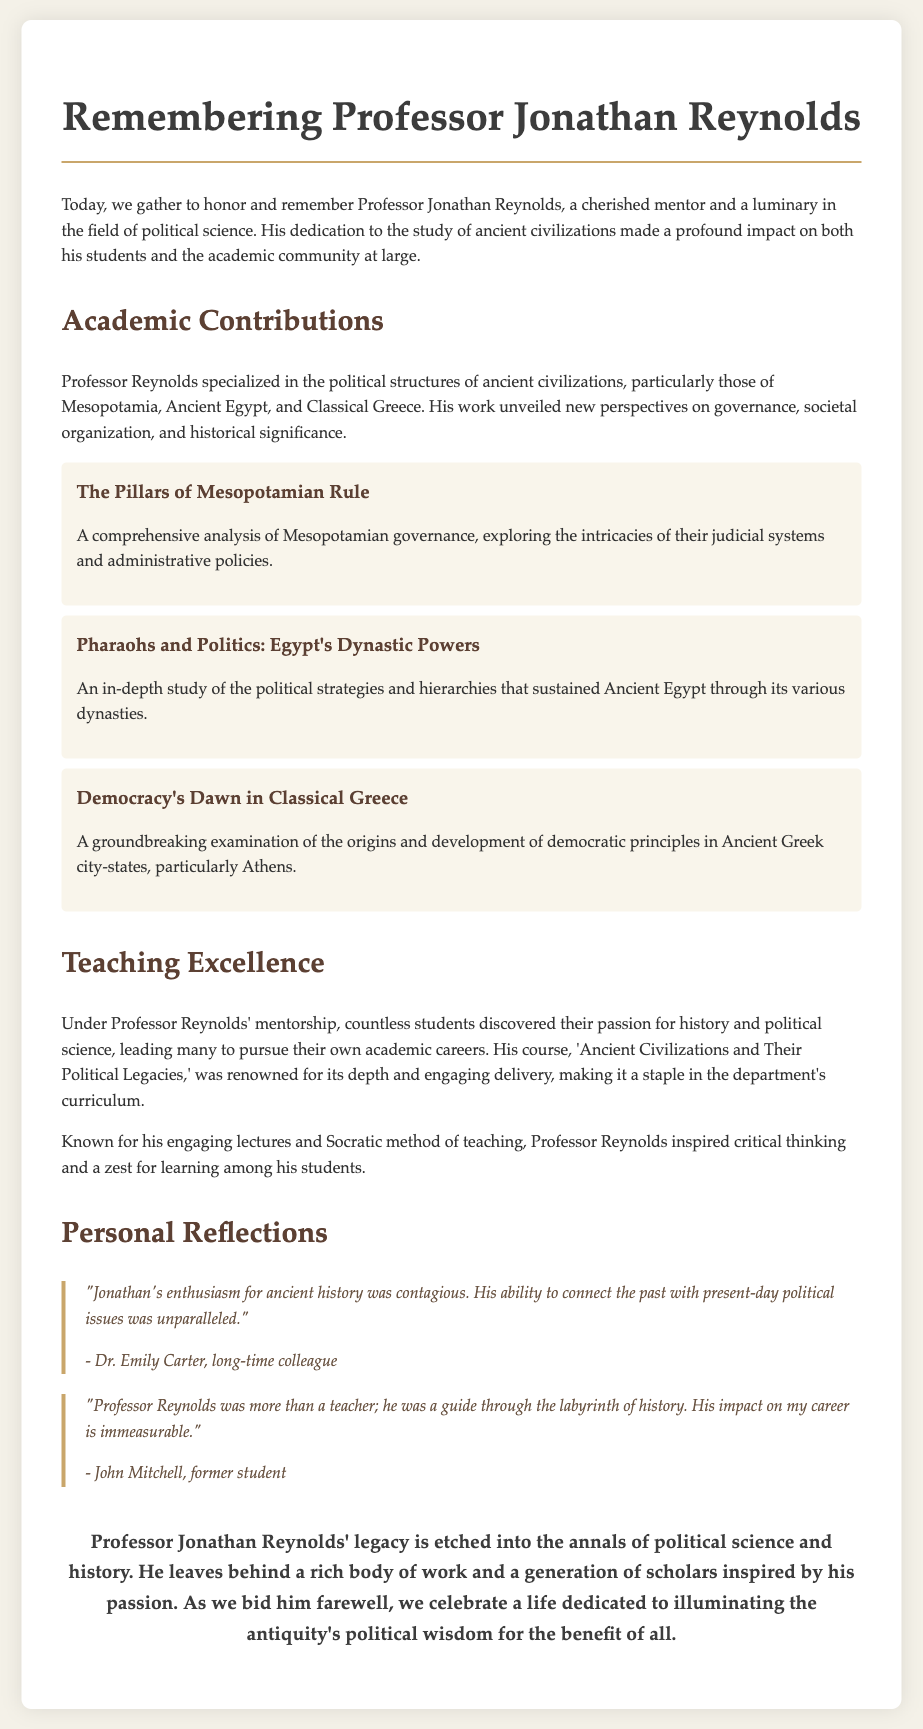What was Professor Reynolds' area of specialization? Professor Reynolds specialized in the political structures of ancient civilizations, particularly in Mesopotamia, Ancient Egypt, and Classical Greece.
Answer: political structures of ancient civilizations What is the title of Professor Reynolds' book on Mesopotamia? The document lists a specific book title focused on Mesopotamia's governance, which is "The Pillars of Mesopotamian Rule."
Answer: The Pillars of Mesopotamian Rule Who described Professor Reynolds' teaching enthusiasm? Dr. Emily Carter, a long-time colleague, shared a reflection on Professor Reynolds' enthusiasm for ancient history.
Answer: Dr. Emily Carter How many significant books are mentioned in the document? Three significant books authored by Professor Reynolds are highlighted in the document.
Answer: three What was the name of the course Professor Reynolds taught? The document specifically names the course that Professor Reynolds taught as "Ancient Civilizations and Their Political Legacies."
Answer: Ancient Civilizations and Their Political Legacies What method of teaching was Professor Reynolds known for? The document mentions that he was known for his engaging lectures and the Socratic method of teaching.
Answer: Socratic method What type of impact did Professor Reynolds have on his students? The document states that countless students discovered their passion for history and political science under his mentorship.
Answer: passion for history and political science What is the concluding sentiment expressed about Professor Reynolds' legacy? The conclusion reflects his impact and celebration of a life dedicated to illuminating antiquity's political wisdom for the benefit of all.
Answer: illuminating antiquity's political wisdom 